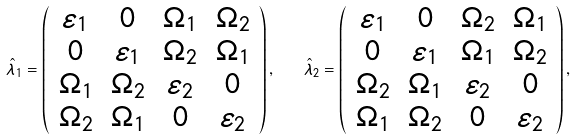<formula> <loc_0><loc_0><loc_500><loc_500>\hat { \lambda } _ { 1 } = \left ( \begin{array} { c c c c } \varepsilon _ { 1 } & 0 & \Omega _ { 1 } & \Omega _ { 2 } \\ 0 & \varepsilon _ { 1 } & \Omega _ { 2 } & \Omega _ { 1 } \\ \Omega _ { 1 } & \Omega _ { 2 } & \varepsilon _ { 2 } & 0 \\ \Omega _ { 2 } & \Omega _ { 1 } & 0 & \varepsilon _ { 2 } \\ \end{array} \right ) , \quad \hat { \lambda } _ { 2 } = \left ( \begin{array} { c c c c } \varepsilon _ { 1 } & 0 & \Omega _ { 2 } & \Omega _ { 1 } \\ 0 & \varepsilon _ { 1 } & \Omega _ { 1 } & \Omega _ { 2 } \\ \Omega _ { 2 } & \Omega _ { 1 } & \varepsilon _ { 2 } & 0 \\ \Omega _ { 1 } & \Omega _ { 2 } & 0 & \varepsilon _ { 2 } \\ \end{array} \right ) ,</formula> 